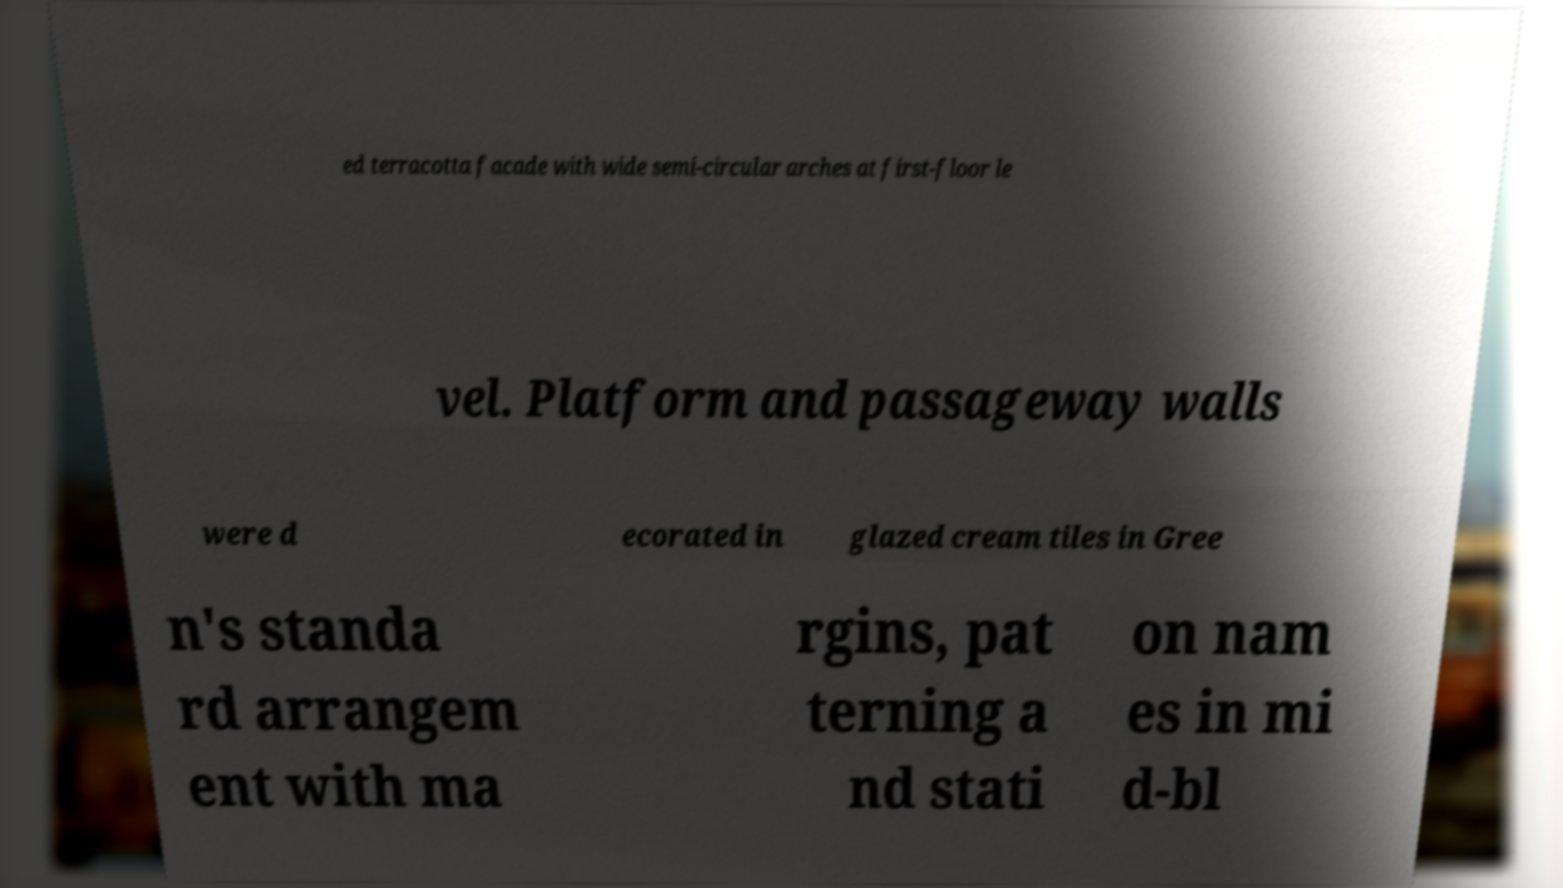I need the written content from this picture converted into text. Can you do that? ed terracotta facade with wide semi-circular arches at first-floor le vel. Platform and passageway walls were d ecorated in glazed cream tiles in Gree n's standa rd arrangem ent with ma rgins, pat terning a nd stati on nam es in mi d-bl 